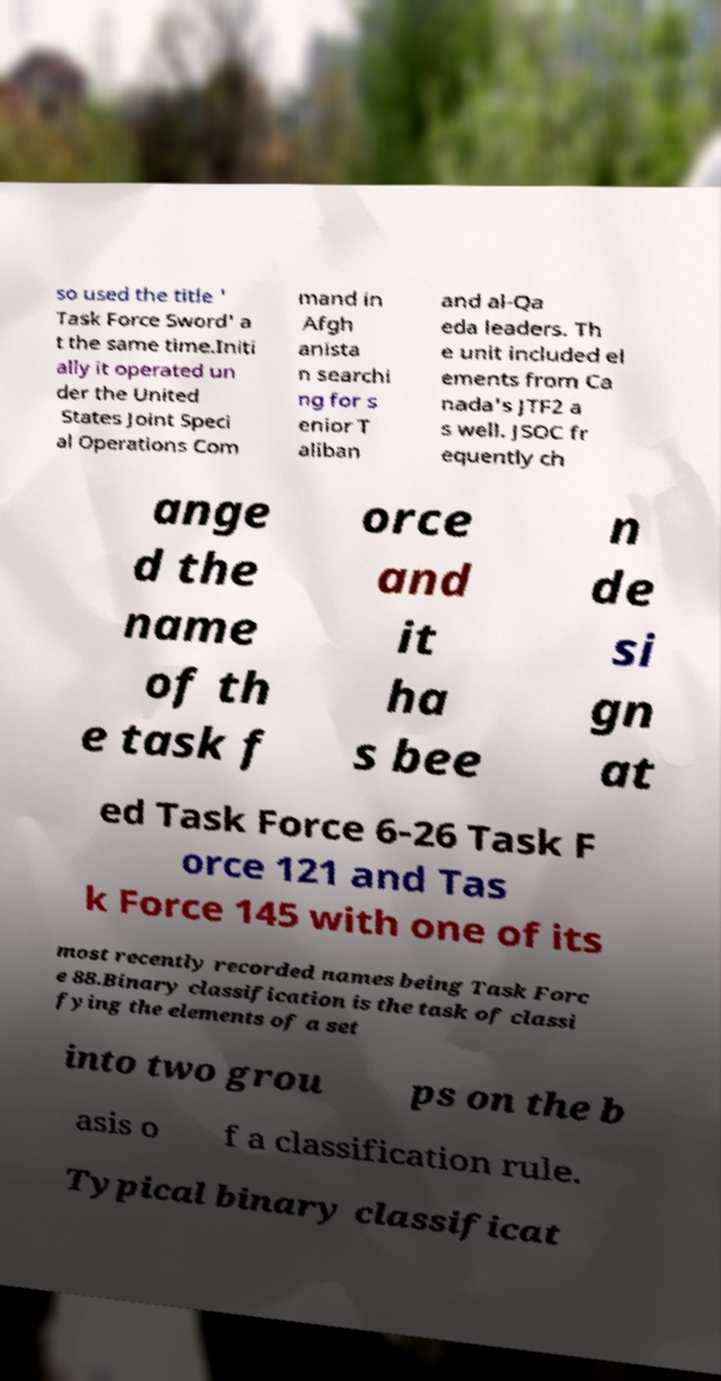There's text embedded in this image that I need extracted. Can you transcribe it verbatim? so used the title ' Task Force Sword' a t the same time.Initi ally it operated un der the United States Joint Speci al Operations Com mand in Afgh anista n searchi ng for s enior T aliban and al-Qa eda leaders. Th e unit included el ements from Ca nada's JTF2 a s well. JSOC fr equently ch ange d the name of th e task f orce and it ha s bee n de si gn at ed Task Force 6-26 Task F orce 121 and Tas k Force 145 with one of its most recently recorded names being Task Forc e 88.Binary classification is the task of classi fying the elements of a set into two grou ps on the b asis o f a classification rule. Typical binary classificat 